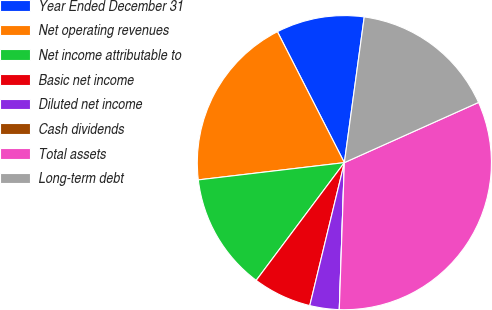Convert chart. <chart><loc_0><loc_0><loc_500><loc_500><pie_chart><fcel>Year Ended December 31<fcel>Net operating revenues<fcel>Net income attributable to<fcel>Basic net income<fcel>Diluted net income<fcel>Cash dividends<fcel>Total assets<fcel>Long-term debt<nl><fcel>9.68%<fcel>19.35%<fcel>12.9%<fcel>6.45%<fcel>3.23%<fcel>0.0%<fcel>32.26%<fcel>16.13%<nl></chart> 